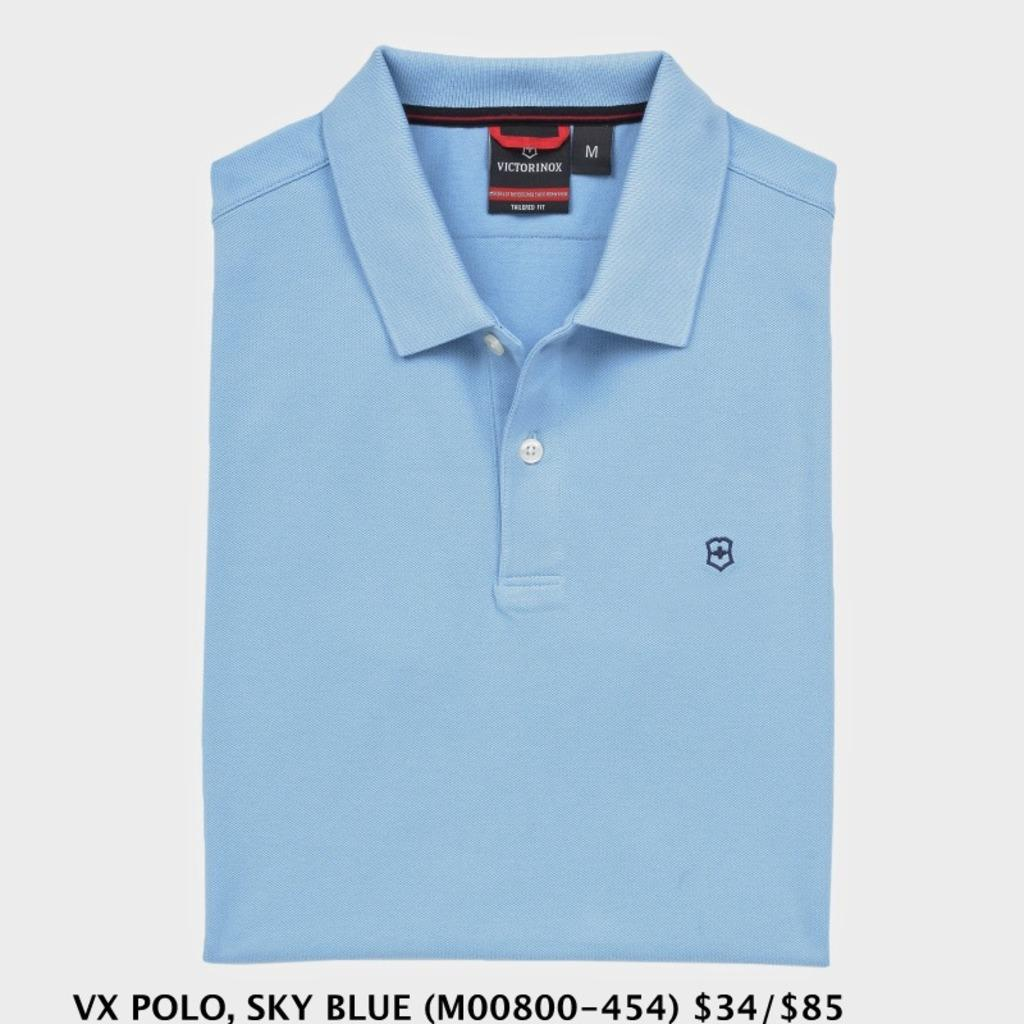Provide a one-sentence caption for the provided image. a folded blue shirt with tag that says victorinox. 